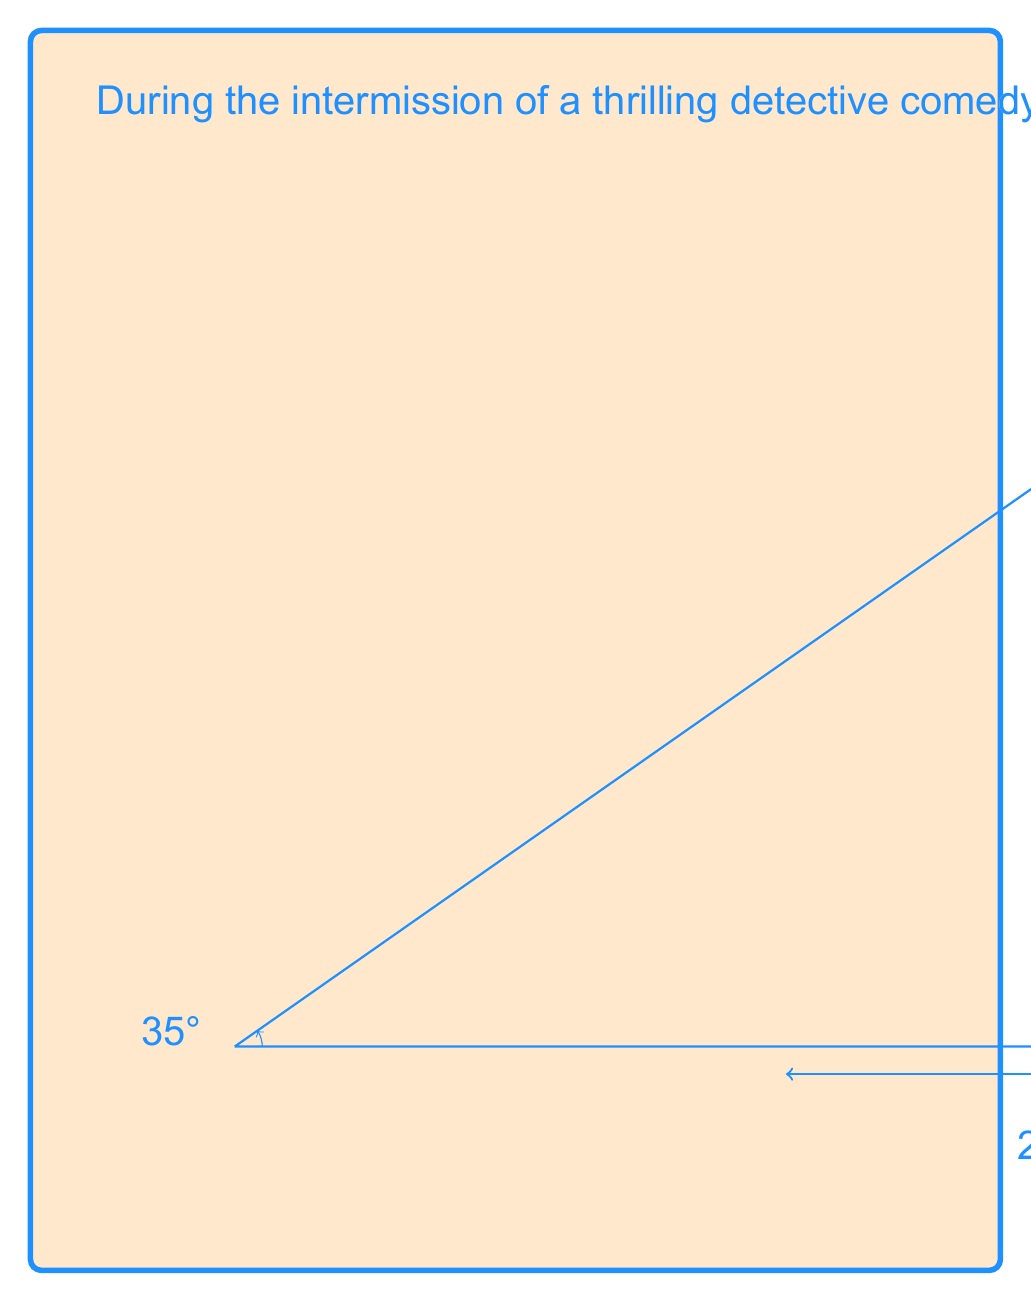Solve this math problem. Let's approach this step-by-step using trigonometric ratios:

1) In this scenario, we have a right triangle. The known parts are:
   - The adjacent side (distance from you to the base of the balcony): 20 meters
   - The angle of elevation: 35°

2) We need to find the opposite side (height of the balcony). The trigonometric ratio that relates the opposite side to the adjacent side is the tangent.

3) The tangent of an angle in a right triangle is defined as:

   $$ \tan \theta = \frac{\text{opposite}}{\text{adjacent}} $$

4) Let's call the height of the balcony $h$. We can set up the equation:

   $$ \tan 35° = \frac{h}{20} $$

5) To solve for $h$, we multiply both sides by 20:

   $$ 20 \tan 35° = h $$

6) Now we can calculate:
   $$ h = 20 \times \tan 35° $$
   $$ h = 20 \times 0.7002075 $$
   $$ h = 14.00415 \text{ meters} $$

7) Rounding to the nearest tenth:
   $$ h \approx 14.0 \text{ meters} $$
Answer: The height of the theater balcony is approximately 14.0 meters. 